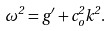Convert formula to latex. <formula><loc_0><loc_0><loc_500><loc_500>\omega ^ { 2 } = g ^ { \prime } + c _ { o } ^ { 2 } k ^ { 2 } .</formula> 